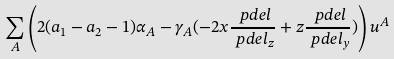Convert formula to latex. <formula><loc_0><loc_0><loc_500><loc_500>& \sum _ { A } \left ( 2 ( a _ { 1 } - a _ { 2 } - 1 ) \alpha _ { A } - \gamma _ { A } ( - 2 x \frac { \ p d e l } { \ p d e l _ { z } } + z \frac { \ p d e l } { \ p d e l _ { y } } ) \right ) u ^ { A }</formula> 